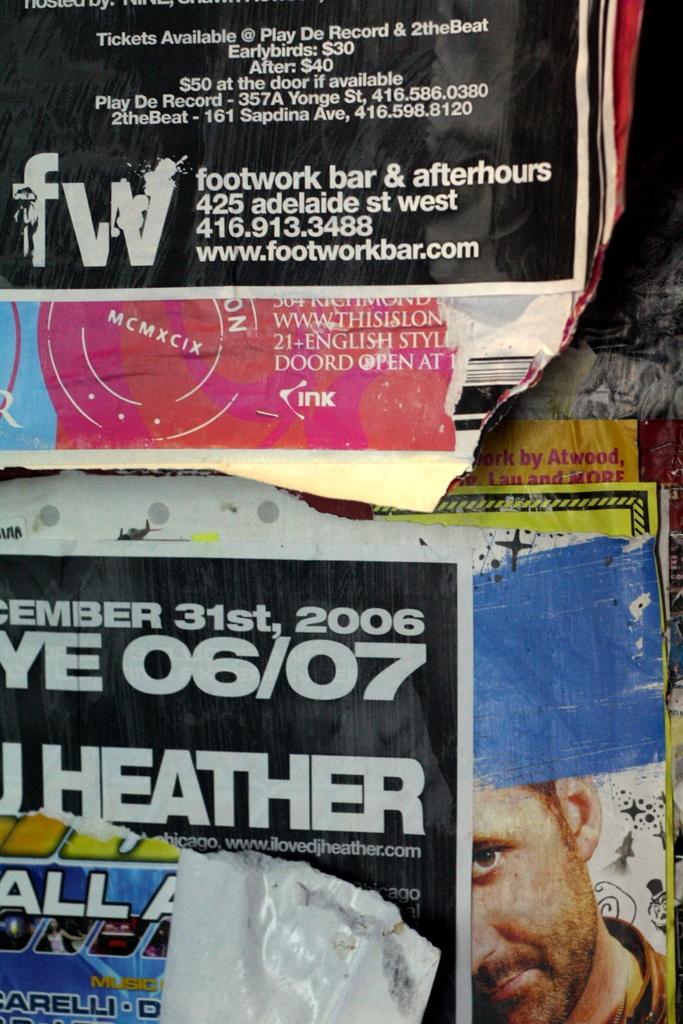Can you describe this image briefly? In this image I can see there are the posters attached to the wall and on the wall, I can see text and a person image 